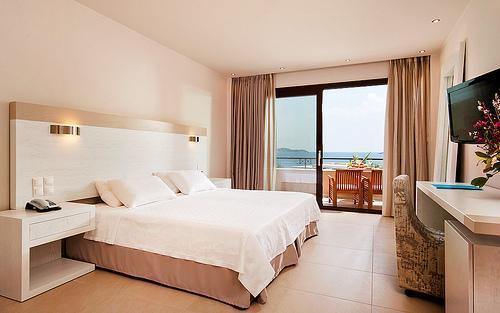How many lamps are on?
Give a very brief answer. 2. 